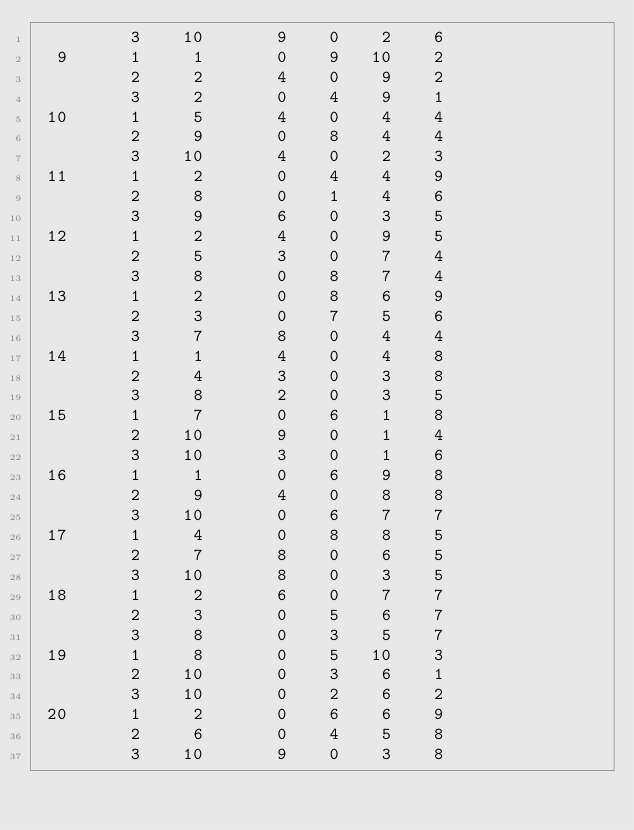Convert code to text. <code><loc_0><loc_0><loc_500><loc_500><_ObjectiveC_>         3    10       9    0    2    6
  9      1     1       0    9   10    2
         2     2       4    0    9    2
         3     2       0    4    9    1
 10      1     5       4    0    4    4
         2     9       0    8    4    4
         3    10       4    0    2    3
 11      1     2       0    4    4    9
         2     8       0    1    4    6
         3     9       6    0    3    5
 12      1     2       4    0    9    5
         2     5       3    0    7    4
         3     8       0    8    7    4
 13      1     2       0    8    6    9
         2     3       0    7    5    6
         3     7       8    0    4    4
 14      1     1       4    0    4    8
         2     4       3    0    3    8
         3     8       2    0    3    5
 15      1     7       0    6    1    8
         2    10       9    0    1    4
         3    10       3    0    1    6
 16      1     1       0    6    9    8
         2     9       4    0    8    8
         3    10       0    6    7    7
 17      1     4       0    8    8    5
         2     7       8    0    6    5
         3    10       8    0    3    5
 18      1     2       6    0    7    7
         2     3       0    5    6    7
         3     8       0    3    5    7
 19      1     8       0    5   10    3
         2    10       0    3    6    1
         3    10       0    2    6    2
 20      1     2       0    6    6    9
         2     6       0    4    5    8
         3    10       9    0    3    8</code> 